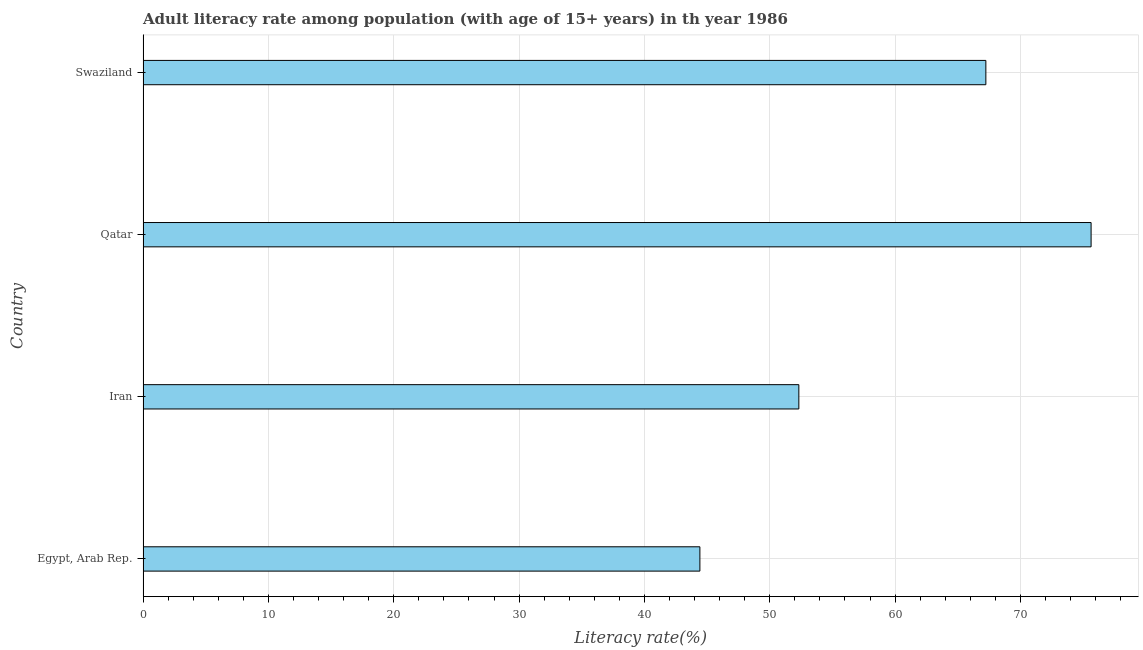Does the graph contain grids?
Ensure brevity in your answer.  Yes. What is the title of the graph?
Provide a short and direct response. Adult literacy rate among population (with age of 15+ years) in th year 1986. What is the label or title of the X-axis?
Give a very brief answer. Literacy rate(%). What is the label or title of the Y-axis?
Make the answer very short. Country. What is the adult literacy rate in Iran?
Your response must be concise. 52.32. Across all countries, what is the maximum adult literacy rate?
Your answer should be compact. 75.64. Across all countries, what is the minimum adult literacy rate?
Offer a very short reply. 44.42. In which country was the adult literacy rate maximum?
Your response must be concise. Qatar. In which country was the adult literacy rate minimum?
Make the answer very short. Egypt, Arab Rep. What is the sum of the adult literacy rate?
Give a very brief answer. 239.62. What is the difference between the adult literacy rate in Iran and Swaziland?
Ensure brevity in your answer.  -14.92. What is the average adult literacy rate per country?
Keep it short and to the point. 59.91. What is the median adult literacy rate?
Offer a terse response. 59.78. In how many countries, is the adult literacy rate greater than 38 %?
Your response must be concise. 4. What is the ratio of the adult literacy rate in Egypt, Arab Rep. to that in Iran?
Give a very brief answer. 0.85. Is the difference between the adult literacy rate in Iran and Qatar greater than the difference between any two countries?
Keep it short and to the point. No. What is the difference between the highest and the second highest adult literacy rate?
Ensure brevity in your answer.  8.4. What is the difference between the highest and the lowest adult literacy rate?
Your response must be concise. 31.21. In how many countries, is the adult literacy rate greater than the average adult literacy rate taken over all countries?
Provide a succinct answer. 2. How many bars are there?
Offer a very short reply. 4. Are all the bars in the graph horizontal?
Make the answer very short. Yes. What is the Literacy rate(%) of Egypt, Arab Rep.?
Your answer should be very brief. 44.42. What is the Literacy rate(%) in Iran?
Give a very brief answer. 52.32. What is the Literacy rate(%) in Qatar?
Give a very brief answer. 75.64. What is the Literacy rate(%) of Swaziland?
Make the answer very short. 67.24. What is the difference between the Literacy rate(%) in Egypt, Arab Rep. and Iran?
Provide a short and direct response. -7.9. What is the difference between the Literacy rate(%) in Egypt, Arab Rep. and Qatar?
Provide a succinct answer. -31.21. What is the difference between the Literacy rate(%) in Egypt, Arab Rep. and Swaziland?
Ensure brevity in your answer.  -22.82. What is the difference between the Literacy rate(%) in Iran and Qatar?
Offer a terse response. -23.32. What is the difference between the Literacy rate(%) in Iran and Swaziland?
Ensure brevity in your answer.  -14.92. What is the difference between the Literacy rate(%) in Qatar and Swaziland?
Offer a very short reply. 8.4. What is the ratio of the Literacy rate(%) in Egypt, Arab Rep. to that in Iran?
Ensure brevity in your answer.  0.85. What is the ratio of the Literacy rate(%) in Egypt, Arab Rep. to that in Qatar?
Your response must be concise. 0.59. What is the ratio of the Literacy rate(%) in Egypt, Arab Rep. to that in Swaziland?
Provide a short and direct response. 0.66. What is the ratio of the Literacy rate(%) in Iran to that in Qatar?
Your answer should be very brief. 0.69. What is the ratio of the Literacy rate(%) in Iran to that in Swaziland?
Provide a short and direct response. 0.78. What is the ratio of the Literacy rate(%) in Qatar to that in Swaziland?
Ensure brevity in your answer.  1.12. 